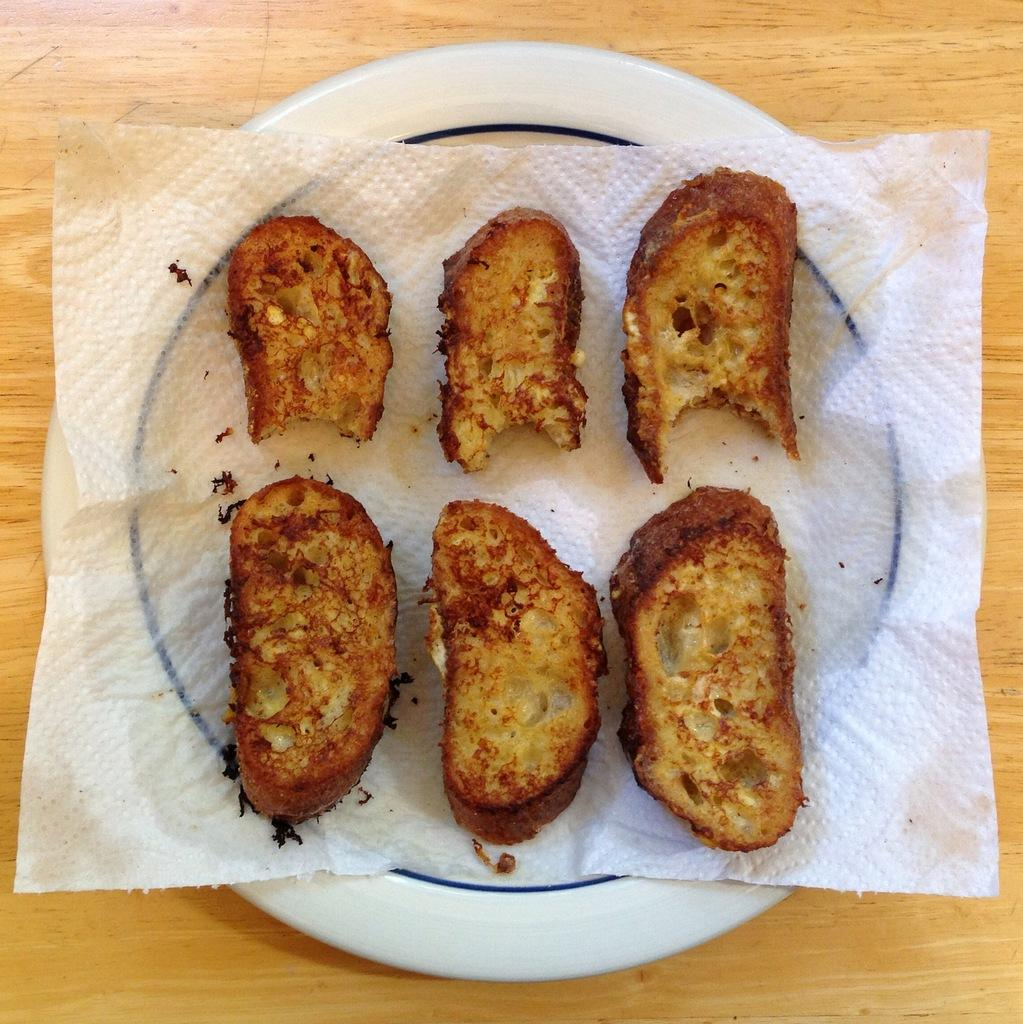What type of food is visible in the image? There are bread slices in the image. How are the bread slices prepared? The bread slices are roasted. Where are the bread slices placed? The bread slices are served on a plate. What is the surface on which the plate is kept? The plate is kept on a wooden table. What type of society is depicted in the image? There is no society depicted in the image; it features roasted bread slices served on a plate. Can you see a monkey in the image? There is no monkey present in the image. 